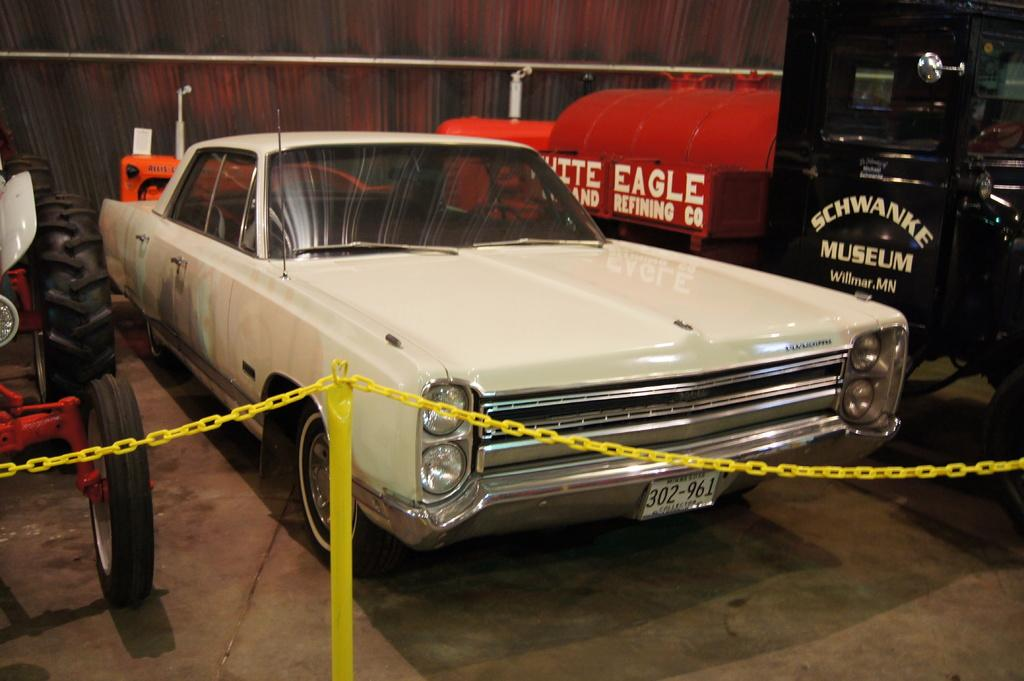What is located at the front of the image? There is a pole in the front of the image. What is attached to the pole? There is a chain on the pole. What can be seen in the background of the image? Vehicles are visible in the background of the image. What type of wool is being spun on the pole in the image? There is no wool or spinning activity present in the image; it only features a pole with a chain. 